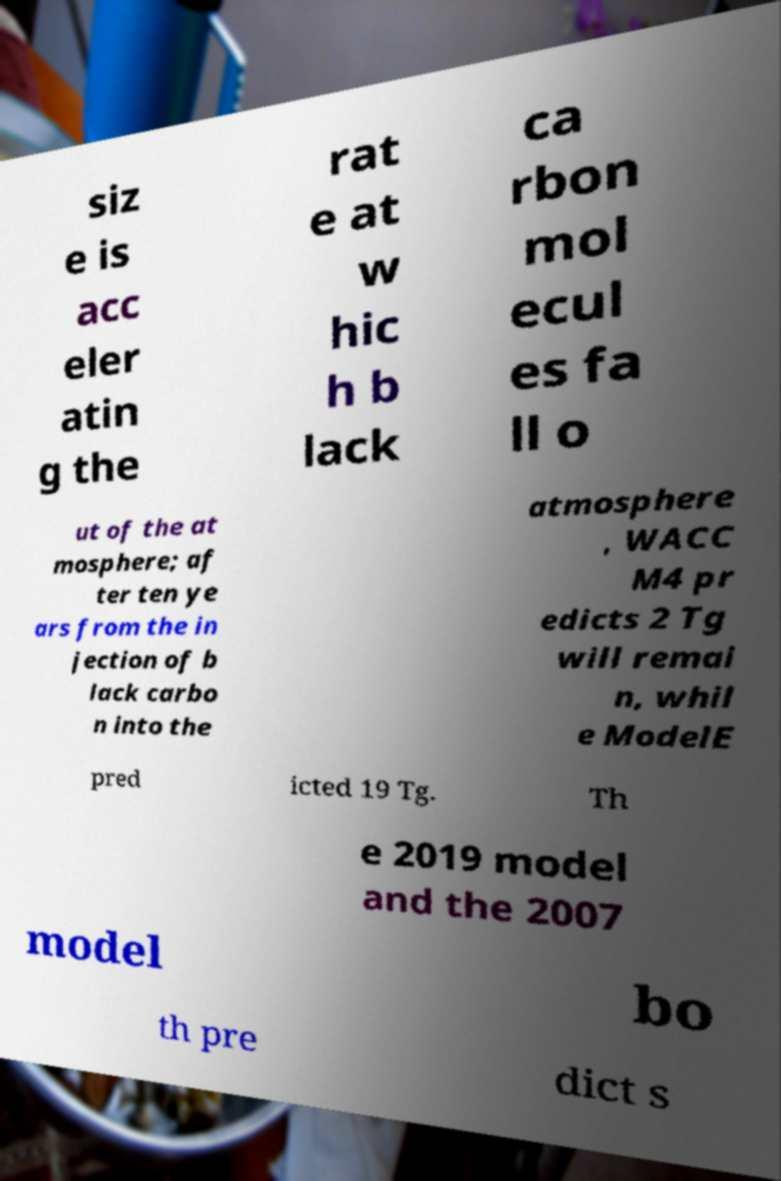Can you accurately transcribe the text from the provided image for me? siz e is acc eler atin g the rat e at w hic h b lack ca rbon mol ecul es fa ll o ut of the at mosphere; af ter ten ye ars from the in jection of b lack carbo n into the atmosphere , WACC M4 pr edicts 2 Tg will remai n, whil e ModelE pred icted 19 Tg. Th e 2019 model and the 2007 model bo th pre dict s 